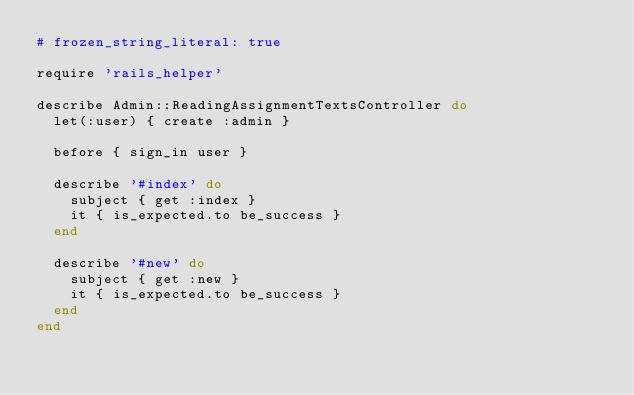Convert code to text. <code><loc_0><loc_0><loc_500><loc_500><_Ruby_># frozen_string_literal: true

require 'rails_helper'

describe Admin::ReadingAssignmentTextsController do
  let(:user) { create :admin }

  before { sign_in user }

  describe '#index' do
    subject { get :index }
    it { is_expected.to be_success }
  end

  describe '#new' do
    subject { get :new }
    it { is_expected.to be_success }
  end
end
</code> 